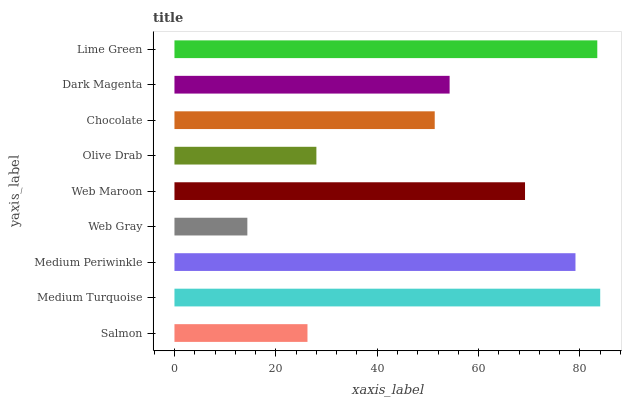Is Web Gray the minimum?
Answer yes or no. Yes. Is Medium Turquoise the maximum?
Answer yes or no. Yes. Is Medium Periwinkle the minimum?
Answer yes or no. No. Is Medium Periwinkle the maximum?
Answer yes or no. No. Is Medium Turquoise greater than Medium Periwinkle?
Answer yes or no. Yes. Is Medium Periwinkle less than Medium Turquoise?
Answer yes or no. Yes. Is Medium Periwinkle greater than Medium Turquoise?
Answer yes or no. No. Is Medium Turquoise less than Medium Periwinkle?
Answer yes or no. No. Is Dark Magenta the high median?
Answer yes or no. Yes. Is Dark Magenta the low median?
Answer yes or no. Yes. Is Olive Drab the high median?
Answer yes or no. No. Is Web Gray the low median?
Answer yes or no. No. 